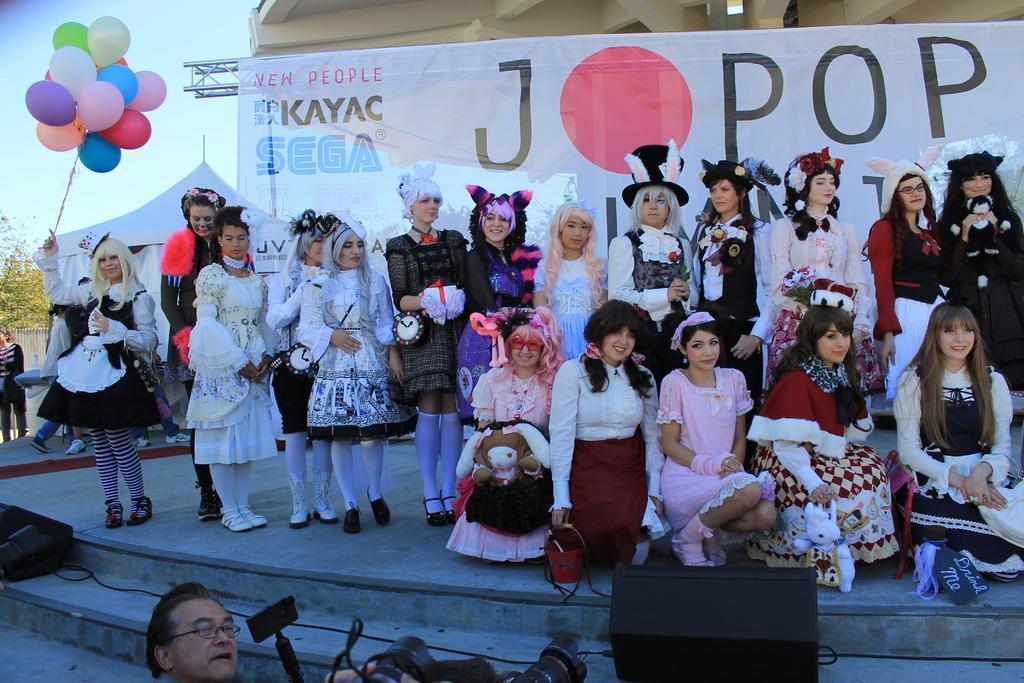Please provide a concise description of this image. In this picture there are people on stage and wore costumes, among them one person holding balloons and we can see banner, truss and tent. In the background of the image we can see leaves and sky. At the bottom of the image there is a head of a man and we can see devices and cameras. 